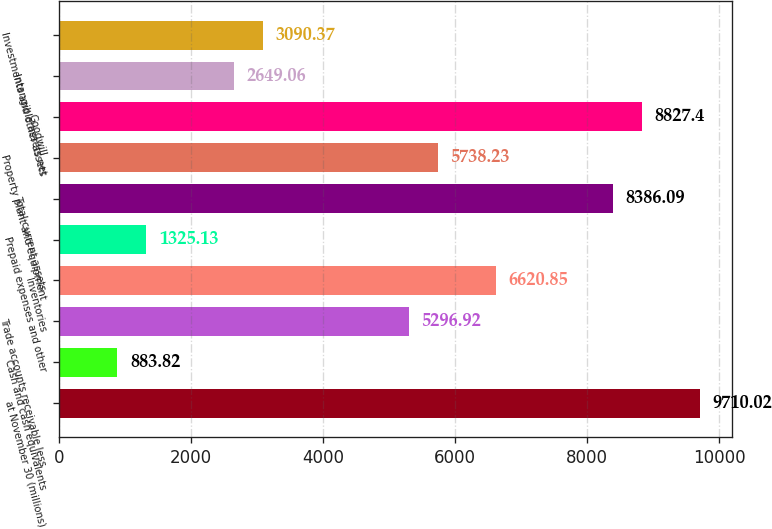Convert chart. <chart><loc_0><loc_0><loc_500><loc_500><bar_chart><fcel>at November 30 (millions)<fcel>Cash and cash equivalents<fcel>Trade accounts receivable less<fcel>Inventories<fcel>Prepaid expenses and other<fcel>Total current assets<fcel>Property plant and equipment<fcel>Goodwill<fcel>Intangible assets net<fcel>Investments and other assets<nl><fcel>9710.02<fcel>883.82<fcel>5296.92<fcel>6620.85<fcel>1325.13<fcel>8386.09<fcel>5738.23<fcel>8827.4<fcel>2649.06<fcel>3090.37<nl></chart> 